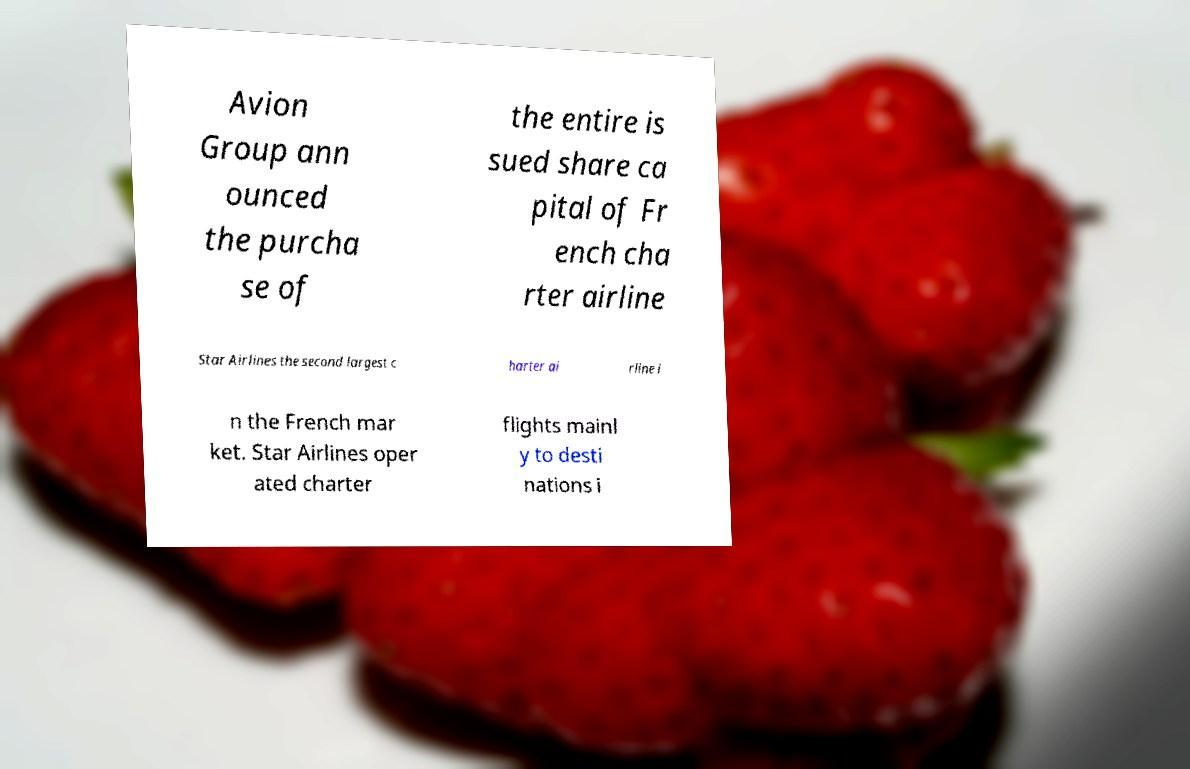Can you read and provide the text displayed in the image?This photo seems to have some interesting text. Can you extract and type it out for me? Avion Group ann ounced the purcha se of the entire is sued share ca pital of Fr ench cha rter airline Star Airlines the second largest c harter ai rline i n the French mar ket. Star Airlines oper ated charter flights mainl y to desti nations i 